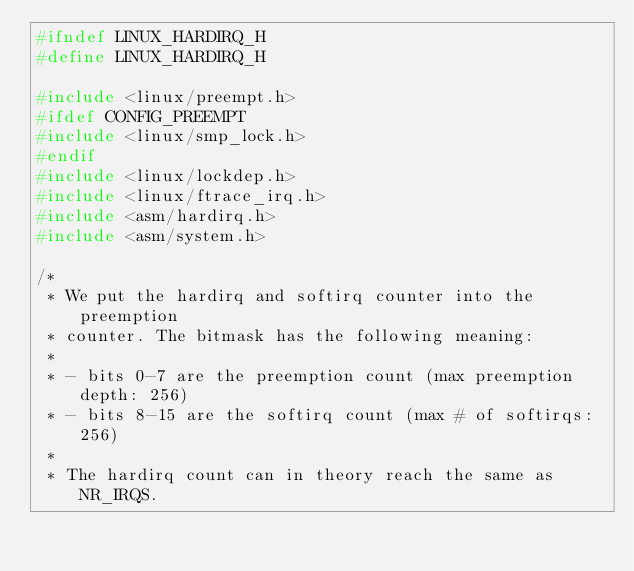Convert code to text. <code><loc_0><loc_0><loc_500><loc_500><_C_>#ifndef LINUX_HARDIRQ_H
#define LINUX_HARDIRQ_H

#include <linux/preempt.h>
#ifdef CONFIG_PREEMPT
#include <linux/smp_lock.h>
#endif
#include <linux/lockdep.h>
#include <linux/ftrace_irq.h>
#include <asm/hardirq.h>
#include <asm/system.h>

/*
 * We put the hardirq and softirq counter into the preemption
 * counter. The bitmask has the following meaning:
 *
 * - bits 0-7 are the preemption count (max preemption depth: 256)
 * - bits 8-15 are the softirq count (max # of softirqs: 256)
 *
 * The hardirq count can in theory reach the same as NR_IRQS.</code> 